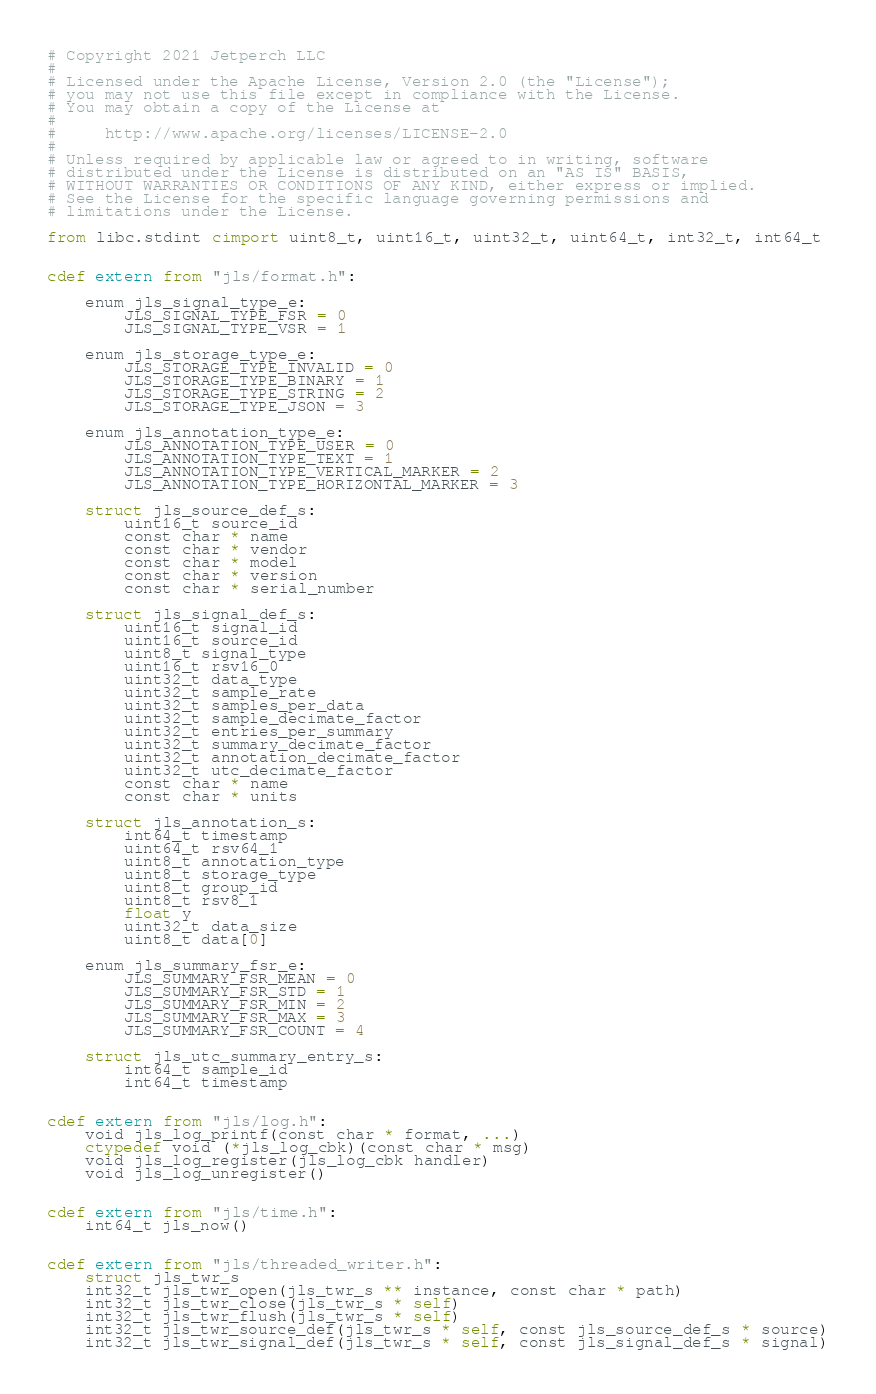Convert code to text. <code><loc_0><loc_0><loc_500><loc_500><_Cython_># Copyright 2021 Jetperch LLC
#
# Licensed under the Apache License, Version 2.0 (the "License");
# you may not use this file except in compliance with the License.
# You may obtain a copy of the License at
#
#     http://www.apache.org/licenses/LICENSE-2.0
#
# Unless required by applicable law or agreed to in writing, software
# distributed under the License is distributed on an "AS IS" BASIS,
# WITHOUT WARRANTIES OR CONDITIONS OF ANY KIND, either express or implied.
# See the License for the specific language governing permissions and
# limitations under the License.

from libc.stdint cimport uint8_t, uint16_t, uint32_t, uint64_t, int32_t, int64_t


cdef extern from "jls/format.h":

    enum jls_signal_type_e:
        JLS_SIGNAL_TYPE_FSR = 0
        JLS_SIGNAL_TYPE_VSR = 1

    enum jls_storage_type_e:
        JLS_STORAGE_TYPE_INVALID = 0
        JLS_STORAGE_TYPE_BINARY = 1
        JLS_STORAGE_TYPE_STRING = 2
        JLS_STORAGE_TYPE_JSON = 3

    enum jls_annotation_type_e:
        JLS_ANNOTATION_TYPE_USER = 0
        JLS_ANNOTATION_TYPE_TEXT = 1
        JLS_ANNOTATION_TYPE_VERTICAL_MARKER = 2
        JLS_ANNOTATION_TYPE_HORIZONTAL_MARKER = 3

    struct jls_source_def_s:
        uint16_t source_id
        const char * name
        const char * vendor
        const char * model
        const char * version
        const char * serial_number

    struct jls_signal_def_s:
        uint16_t signal_id
        uint16_t source_id
        uint8_t signal_type
        uint16_t rsv16_0
        uint32_t data_type
        uint32_t sample_rate
        uint32_t samples_per_data
        uint32_t sample_decimate_factor
        uint32_t entries_per_summary
        uint32_t summary_decimate_factor
        uint32_t annotation_decimate_factor
        uint32_t utc_decimate_factor
        const char * name
        const char * units

    struct jls_annotation_s:
        int64_t timestamp
        uint64_t rsv64_1
        uint8_t annotation_type
        uint8_t storage_type
        uint8_t group_id
        uint8_t rsv8_1
        float y
        uint32_t data_size
        uint8_t data[0]

    enum jls_summary_fsr_e:
        JLS_SUMMARY_FSR_MEAN = 0
        JLS_SUMMARY_FSR_STD = 1
        JLS_SUMMARY_FSR_MIN = 2
        JLS_SUMMARY_FSR_MAX = 3
        JLS_SUMMARY_FSR_COUNT = 4

    struct jls_utc_summary_entry_s:
        int64_t sample_id
        int64_t timestamp


cdef extern from "jls/log.h":
    void jls_log_printf(const char * format, ...)
    ctypedef void (*jls_log_cbk)(const char * msg)
    void jls_log_register(jls_log_cbk handler)
    void jls_log_unregister()


cdef extern from "jls/time.h":
    int64_t jls_now()


cdef extern from "jls/threaded_writer.h":
    struct jls_twr_s
    int32_t jls_twr_open(jls_twr_s ** instance, const char * path)
    int32_t jls_twr_close(jls_twr_s * self)
    int32_t jls_twr_flush(jls_twr_s * self)
    int32_t jls_twr_source_def(jls_twr_s * self, const jls_source_def_s * source)
    int32_t jls_twr_signal_def(jls_twr_s * self, const jls_signal_def_s * signal)</code> 